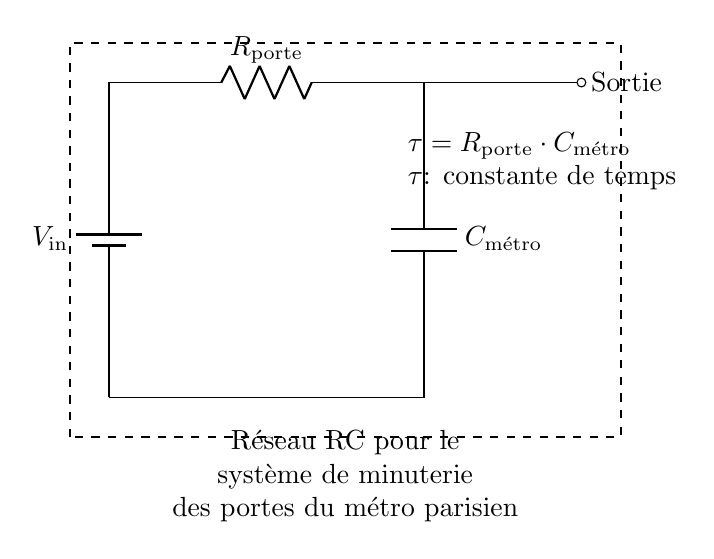What components are used in this circuit? The circuit includes a battery, a resistor, and a capacitor. By examining the diagram, the symbols represent these components clearly, confirming their presence.
Answer: Battery, resistor, capacitor What is the purpose of the resistor in this RC network? The resistor limits the current flow and determines the time it takes for the capacitor to charge or discharge. The relationship between the resistor and capacitor defines the time constant, which is crucial for the timing function in the system.
Answer: Limit current What is the time constant of this circuit? The time constant is calculated using the formula tau equals R times C. The label in the diagram indicates that tau is equal to the product of the resistor value and capacitor value, so you can reference those component values directly from the circuit.
Answer: R porte times C métro What connects the battery to the circuit? The battery is connected in series with the resistor and capacitor through the circuit's wiring. This direct connection allows for the flow of current from the battery through the resistor to the capacitor and back, which is essential for the operation of the timing system.
Answer: Series connection What happens to the capacitor when the door is closing? As the door closes, the capacitor charges through the resistor until it reaches a voltage close to that of the input voltage. This charging behavior is governed by the time constant, indicating how quickly the capacitor fills its voltage, allowing for proper timing of the door closure.
Answer: Capacitor charges How does the arrangement of the components affect the timing? The arrangement impacts how long it takes the circuit to reach a certain voltage across the capacitor, which influences the timing of the door sequences. Changes in the resistor or capacitor values will alter the RC time constant, ultimately affecting how long it takes for the system to respond.
Answer: Affects timing 